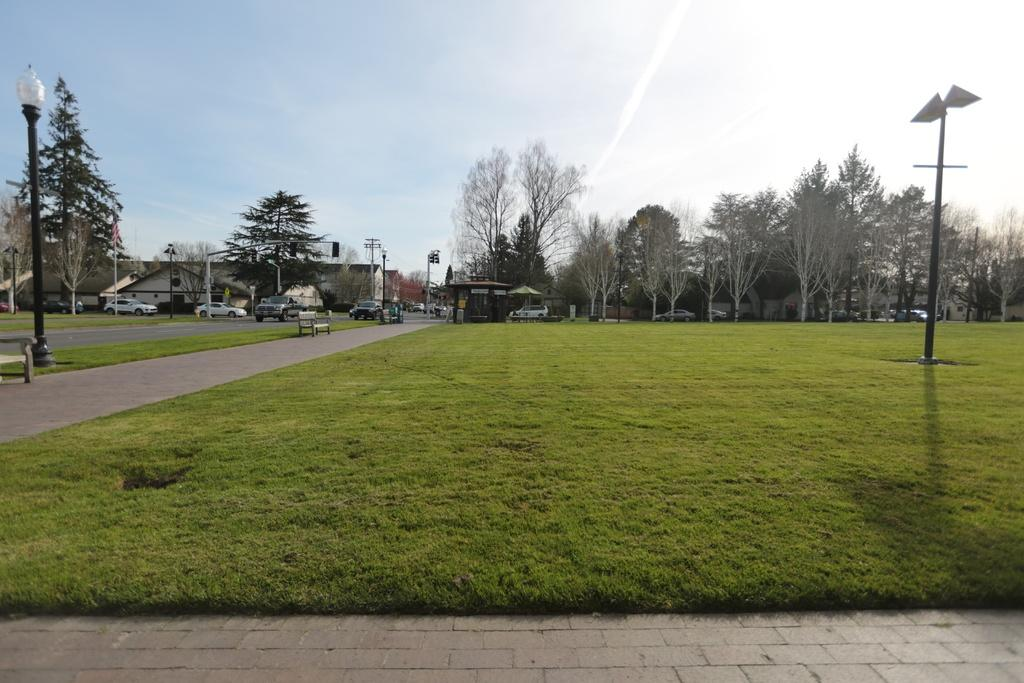What type of vegetation is present on the ground in the center of the image? There is grass on the ground in the center of the image. What can be seen in the background of the image? There are trees, cars, buildings, and poles in the background of the image. What is the condition of the sky in the image? The sky is cloudy in the image. What position does the basin hold in the image? There is no basin present in the image. What statement can be made about the image based on the absence of a basin? The absence of a basin in the image does not affect the overall composition or meaning of the image. 